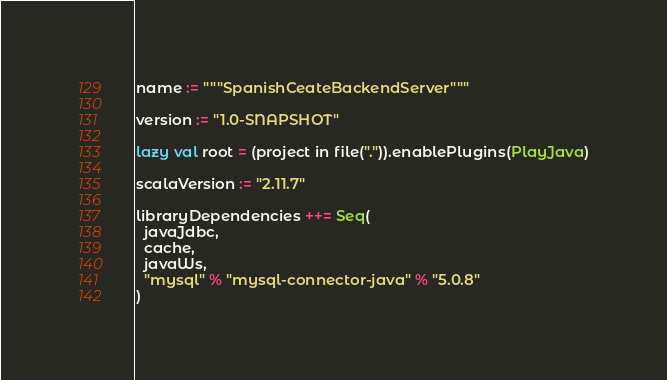Convert code to text. <code><loc_0><loc_0><loc_500><loc_500><_Scala_>name := """SpanishCeateBackendServer"""

version := "1.0-SNAPSHOT"

lazy val root = (project in file(".")).enablePlugins(PlayJava)

scalaVersion := "2.11.7"

libraryDependencies ++= Seq(
  javaJdbc,
  cache,
  javaWs,
  "mysql" % "mysql-connector-java" % "5.0.8"
)
</code> 